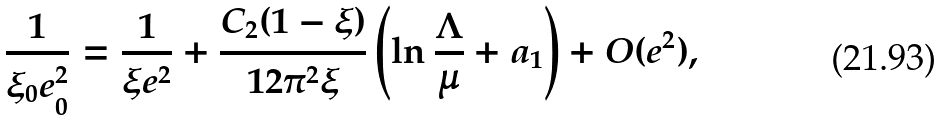Convert formula to latex. <formula><loc_0><loc_0><loc_500><loc_500>\frac { 1 } { \xi _ { 0 } e _ { 0 } ^ { 2 } } = \frac { 1 } { \xi e ^ { 2 } } + \frac { C _ { 2 } ( 1 - \xi ) } { 1 2 \pi ^ { 2 } \xi } \left ( \ln \frac { \Lambda } { \mu } + a _ { 1 } \right ) + O ( e ^ { 2 } ) ,</formula> 